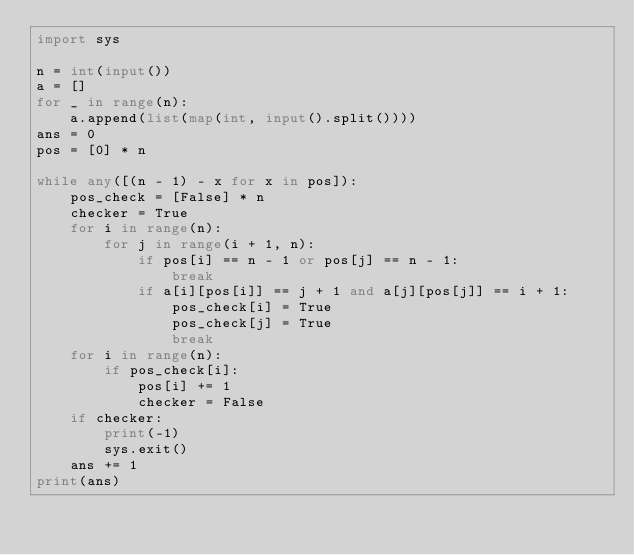<code> <loc_0><loc_0><loc_500><loc_500><_Python_>import sys

n = int(input())
a = []
for _ in range(n):
    a.append(list(map(int, input().split())))
ans = 0
pos = [0] * n

while any([(n - 1) - x for x in pos]):
    pos_check = [False] * n
    checker = True
    for i in range(n):
        for j in range(i + 1, n):
            if pos[i] == n - 1 or pos[j] == n - 1:
                break
            if a[i][pos[i]] == j + 1 and a[j][pos[j]] == i + 1:
                pos_check[i] = True
                pos_check[j] = True
                break
    for i in range(n):
        if pos_check[i]:
            pos[i] += 1
            checker = False
    if checker:
        print(-1)
        sys.exit()
    ans += 1
print(ans)
</code> 